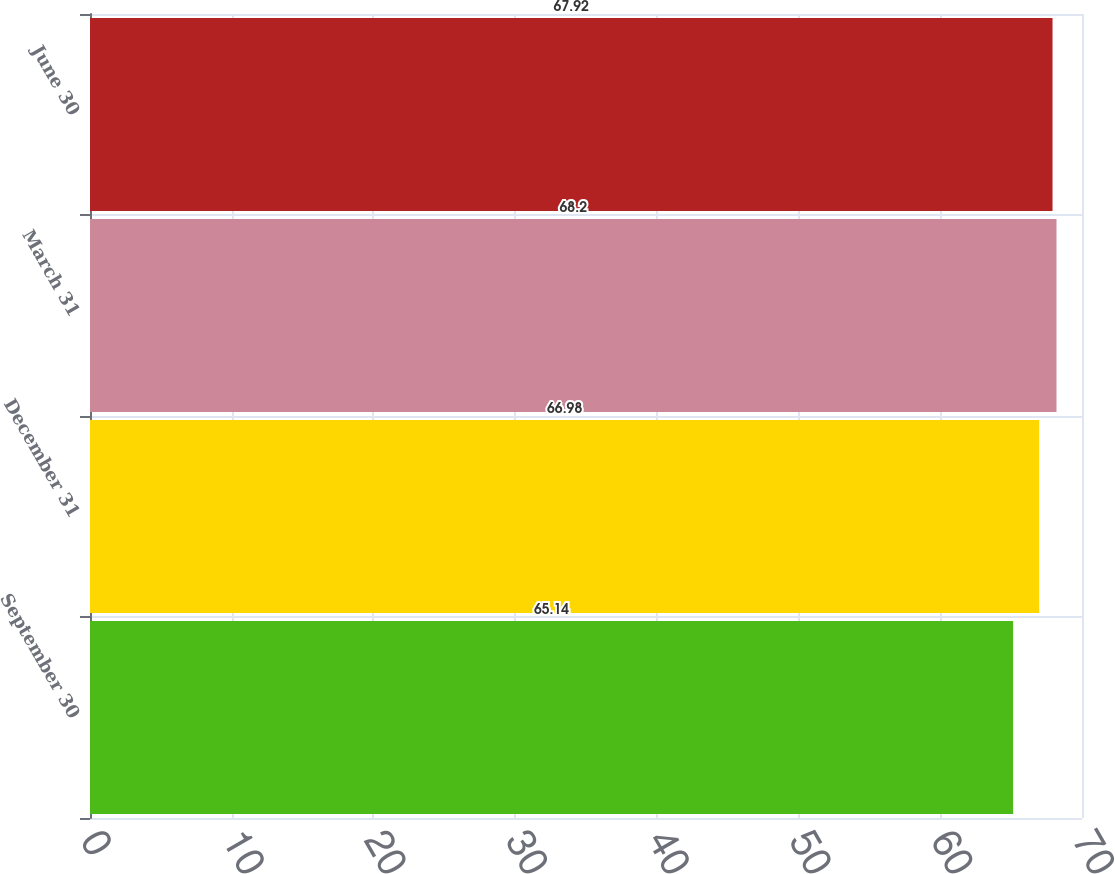<chart> <loc_0><loc_0><loc_500><loc_500><bar_chart><fcel>September 30<fcel>December 31<fcel>March 31<fcel>June 30<nl><fcel>65.14<fcel>66.98<fcel>68.2<fcel>67.92<nl></chart> 